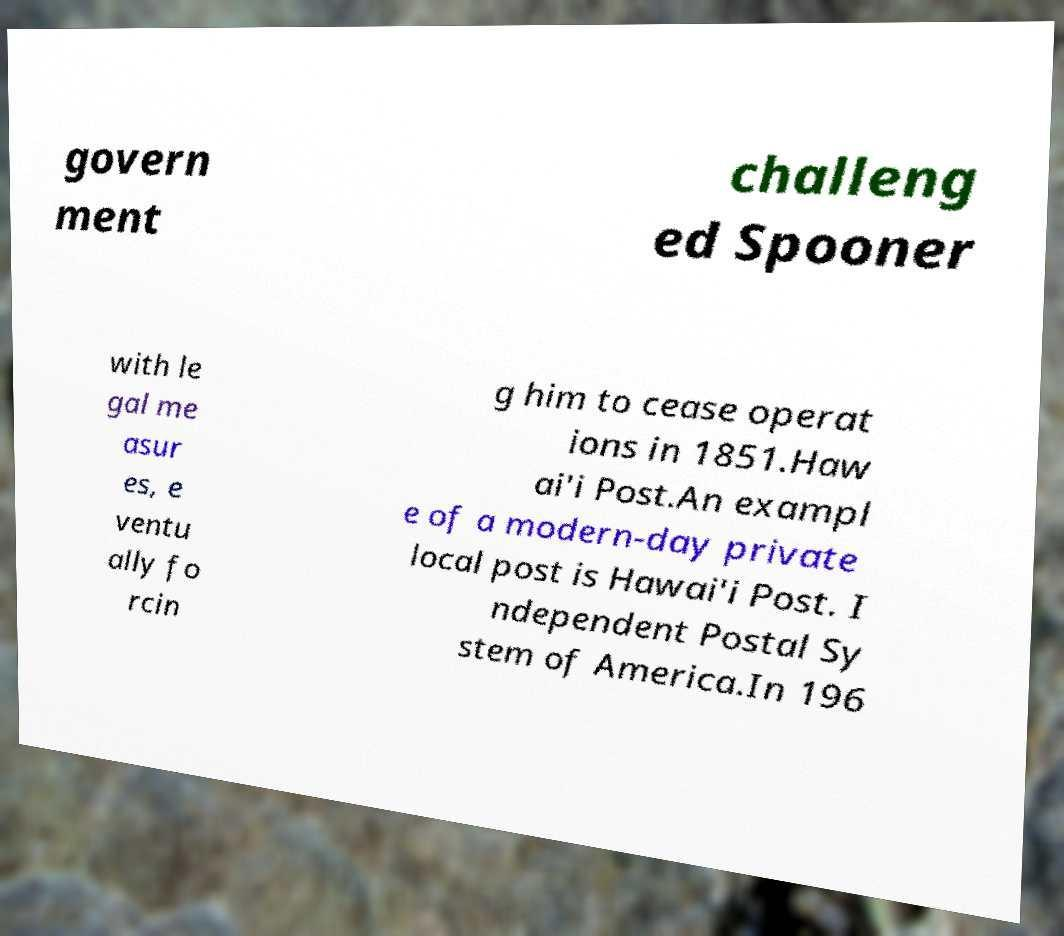There's text embedded in this image that I need extracted. Can you transcribe it verbatim? govern ment challeng ed Spooner with le gal me asur es, e ventu ally fo rcin g him to cease operat ions in 1851.Haw ai'i Post.An exampl e of a modern-day private local post is Hawai'i Post. I ndependent Postal Sy stem of America.In 196 